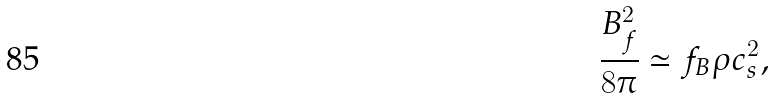Convert formula to latex. <formula><loc_0><loc_0><loc_500><loc_500>\frac { B _ { f } ^ { 2 } } { 8 \pi } \simeq f _ { B } \rho c _ { s } ^ { 2 } ,</formula> 